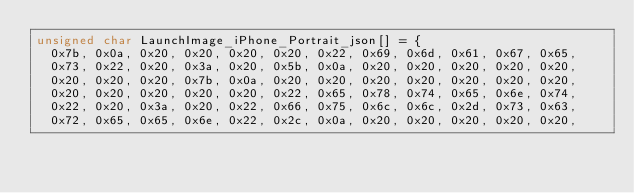Convert code to text. <code><loc_0><loc_0><loc_500><loc_500><_C_>unsigned char LaunchImage_iPhone_Portrait_json[] = {
  0x7b, 0x0a, 0x20, 0x20, 0x20, 0x20, 0x22, 0x69, 0x6d, 0x61, 0x67, 0x65,
  0x73, 0x22, 0x20, 0x3a, 0x20, 0x5b, 0x0a, 0x20, 0x20, 0x20, 0x20, 0x20,
  0x20, 0x20, 0x20, 0x7b, 0x0a, 0x20, 0x20, 0x20, 0x20, 0x20, 0x20, 0x20,
  0x20, 0x20, 0x20, 0x20, 0x20, 0x22, 0x65, 0x78, 0x74, 0x65, 0x6e, 0x74,
  0x22, 0x20, 0x3a, 0x20, 0x22, 0x66, 0x75, 0x6c, 0x6c, 0x2d, 0x73, 0x63,
  0x72, 0x65, 0x65, 0x6e, 0x22, 0x2c, 0x0a, 0x20, 0x20, 0x20, 0x20, 0x20,</code> 